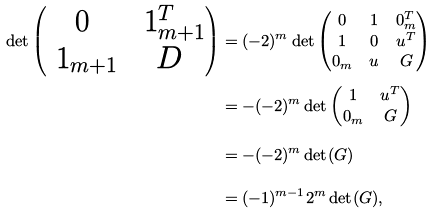<formula> <loc_0><loc_0><loc_500><loc_500>\det \begin{pmatrix} 0 & \ 1 _ { m + 1 } ^ { T } \\ \ 1 _ { m + 1 } & D \end{pmatrix} & = ( - 2 ) ^ { m } \det \begin{pmatrix} 0 & 1 & 0 _ { m } ^ { T } \\ 1 & 0 & u ^ { T } \\ 0 _ { m } & u & G \end{pmatrix} \\ & = - ( - 2 ) ^ { m } \det \begin{pmatrix} 1 & u ^ { T } \\ 0 _ { m } & G \end{pmatrix} \\ & = - ( - 2 ) ^ { m } \det ( G ) \\ & = ( - 1 ) ^ { m - 1 } 2 ^ { m } \det ( G ) ,</formula> 